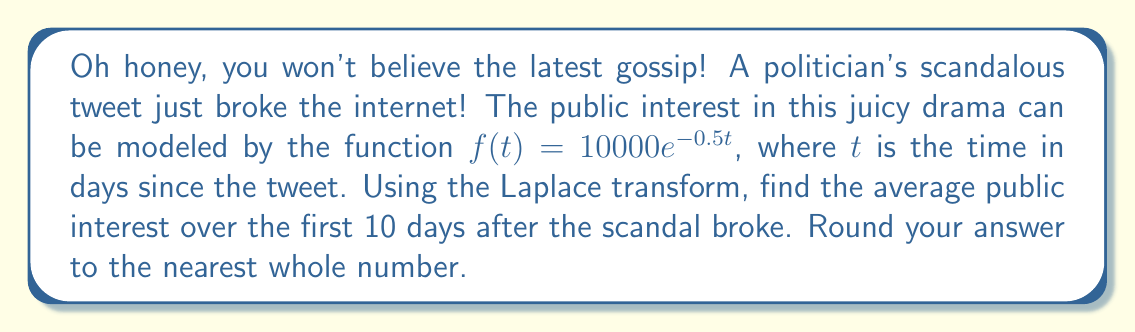Provide a solution to this math problem. Alright, dearie, let's break this down step-by-step:

1) The Laplace transform of $f(t) = 10000e^{-0.5t}$ is:
   $$F(s) = \frac{10000}{s + 0.5}$$

2) To find the average over 10 days, we need to use the formula:
   $$\text{Average} = \frac{1}{T}\int_0^T f(t) dt$$
   where $T = 10$ in this case.

3) In the s-domain, this is equivalent to:
   $$\text{Average} = \frac{1}{T} \cdot \frac{F(s)}{s} \bigg|_{s=0}$$

4) Let's substitute our values:
   $$\text{Average} = \frac{1}{10} \cdot \frac{10000}{s(s + 0.5)} \bigg|_{s=0}$$

5) To evaluate this at $s=0$, we need to use L'Hôpital's rule twice:
   $$\text{Average} = \frac{1}{10} \cdot \lim_{s \to 0} \frac{10000}{s(s + 0.5)}$$
   $$= \frac{1}{10} \cdot \lim_{s \to 0} \frac{10000}{0.5s + s^2}$$
   $$= \frac{1}{10} \cdot \frac{10000}{0.5} = 2000$$

6) Therefore, the average public interest over the first 10 days is 2000.
Answer: 2000 